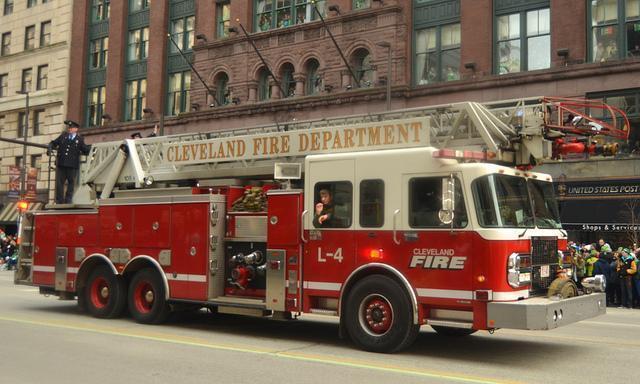What state is this city in?
Select the correct answer and articulate reasoning with the following format: 'Answer: answer
Rationale: rationale.'
Options: Illinois, new zealand, new york, ohio. Answer: ohio.
Rationale: Cleveland is in ohio. 